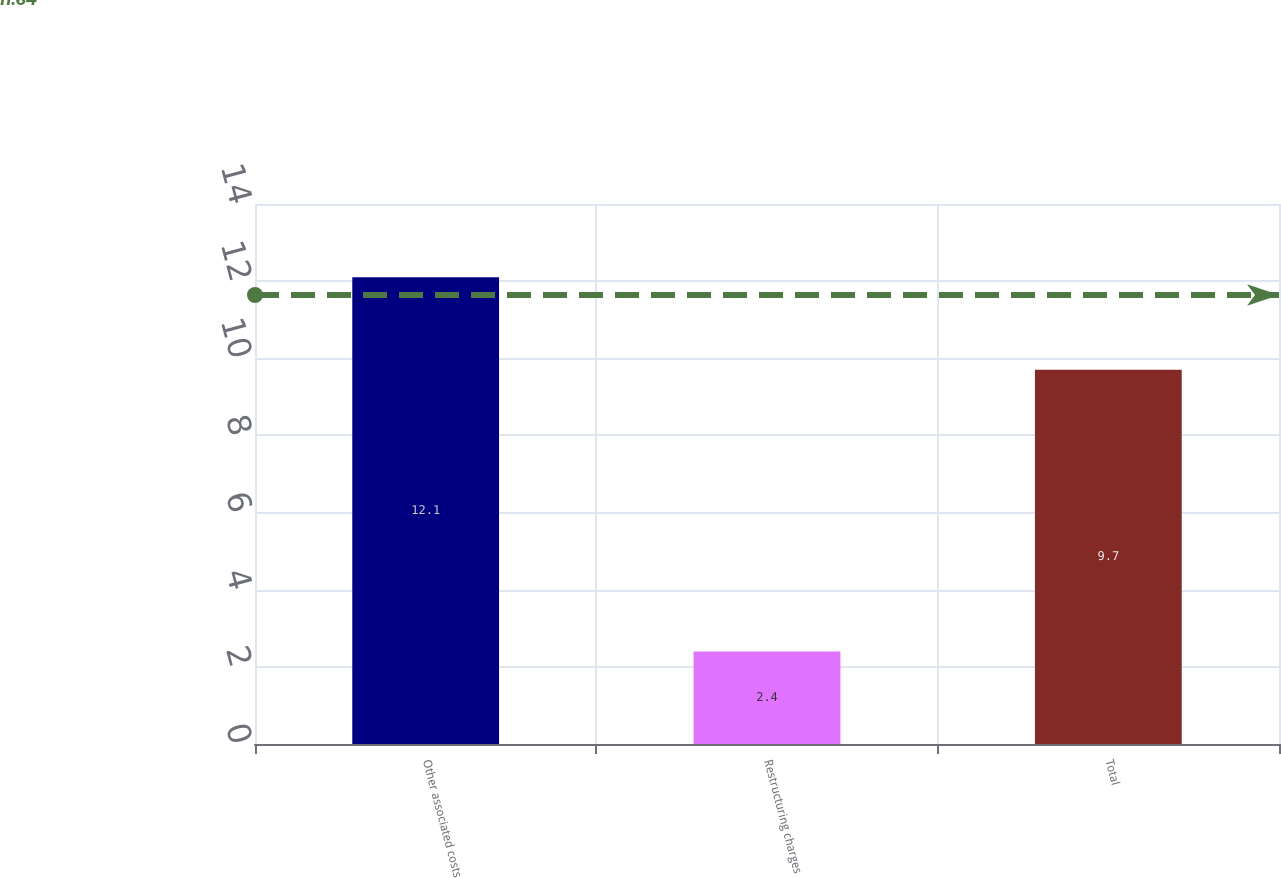Convert chart. <chart><loc_0><loc_0><loc_500><loc_500><bar_chart><fcel>Other associated costs<fcel>Restructuring charges<fcel>Total<nl><fcel>12.1<fcel>2.4<fcel>9.7<nl></chart> 